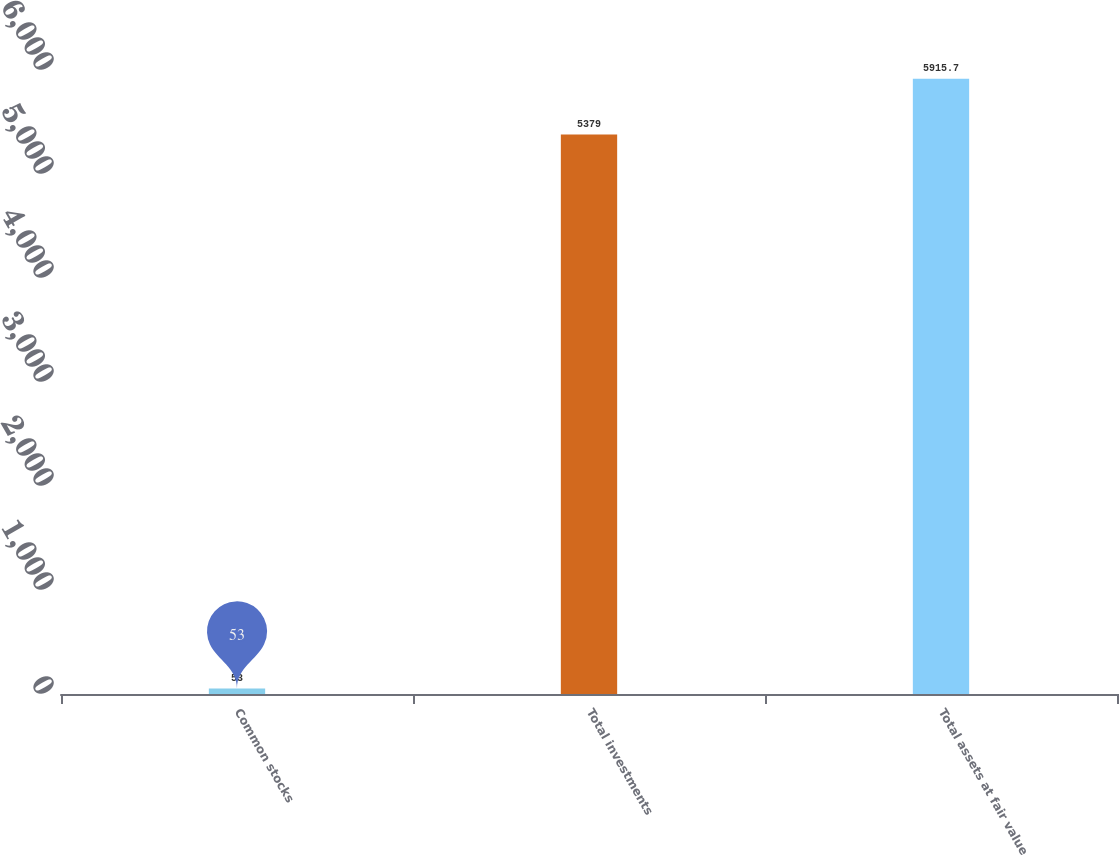<chart> <loc_0><loc_0><loc_500><loc_500><bar_chart><fcel>Common stocks<fcel>Total investments<fcel>Total assets at fair value<nl><fcel>53<fcel>5379<fcel>5915.7<nl></chart> 